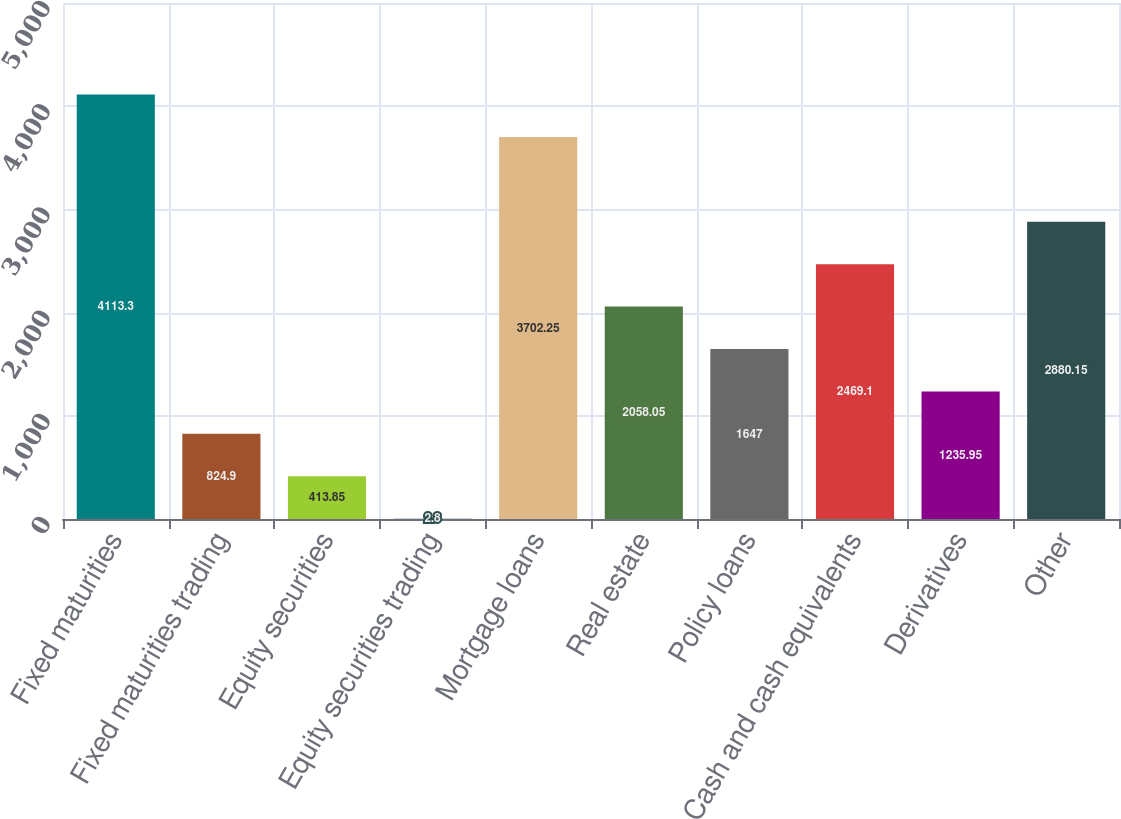Convert chart to OTSL. <chart><loc_0><loc_0><loc_500><loc_500><bar_chart><fcel>Fixed maturities<fcel>Fixed maturities trading<fcel>Equity securities<fcel>Equity securities trading<fcel>Mortgage loans<fcel>Real estate<fcel>Policy loans<fcel>Cash and cash equivalents<fcel>Derivatives<fcel>Other<nl><fcel>4113.3<fcel>824.9<fcel>413.85<fcel>2.8<fcel>3702.25<fcel>2058.05<fcel>1647<fcel>2469.1<fcel>1235.95<fcel>2880.15<nl></chart> 